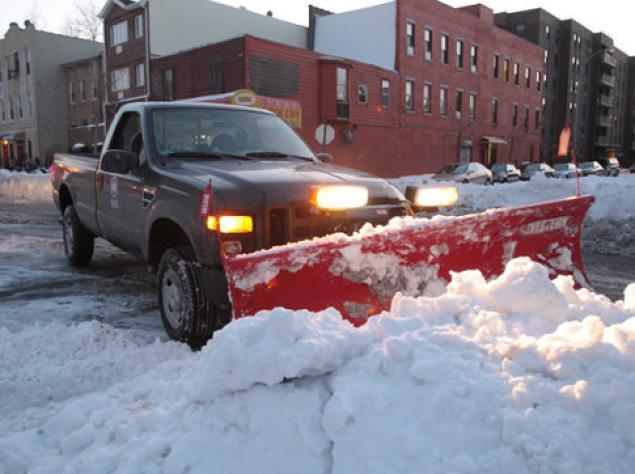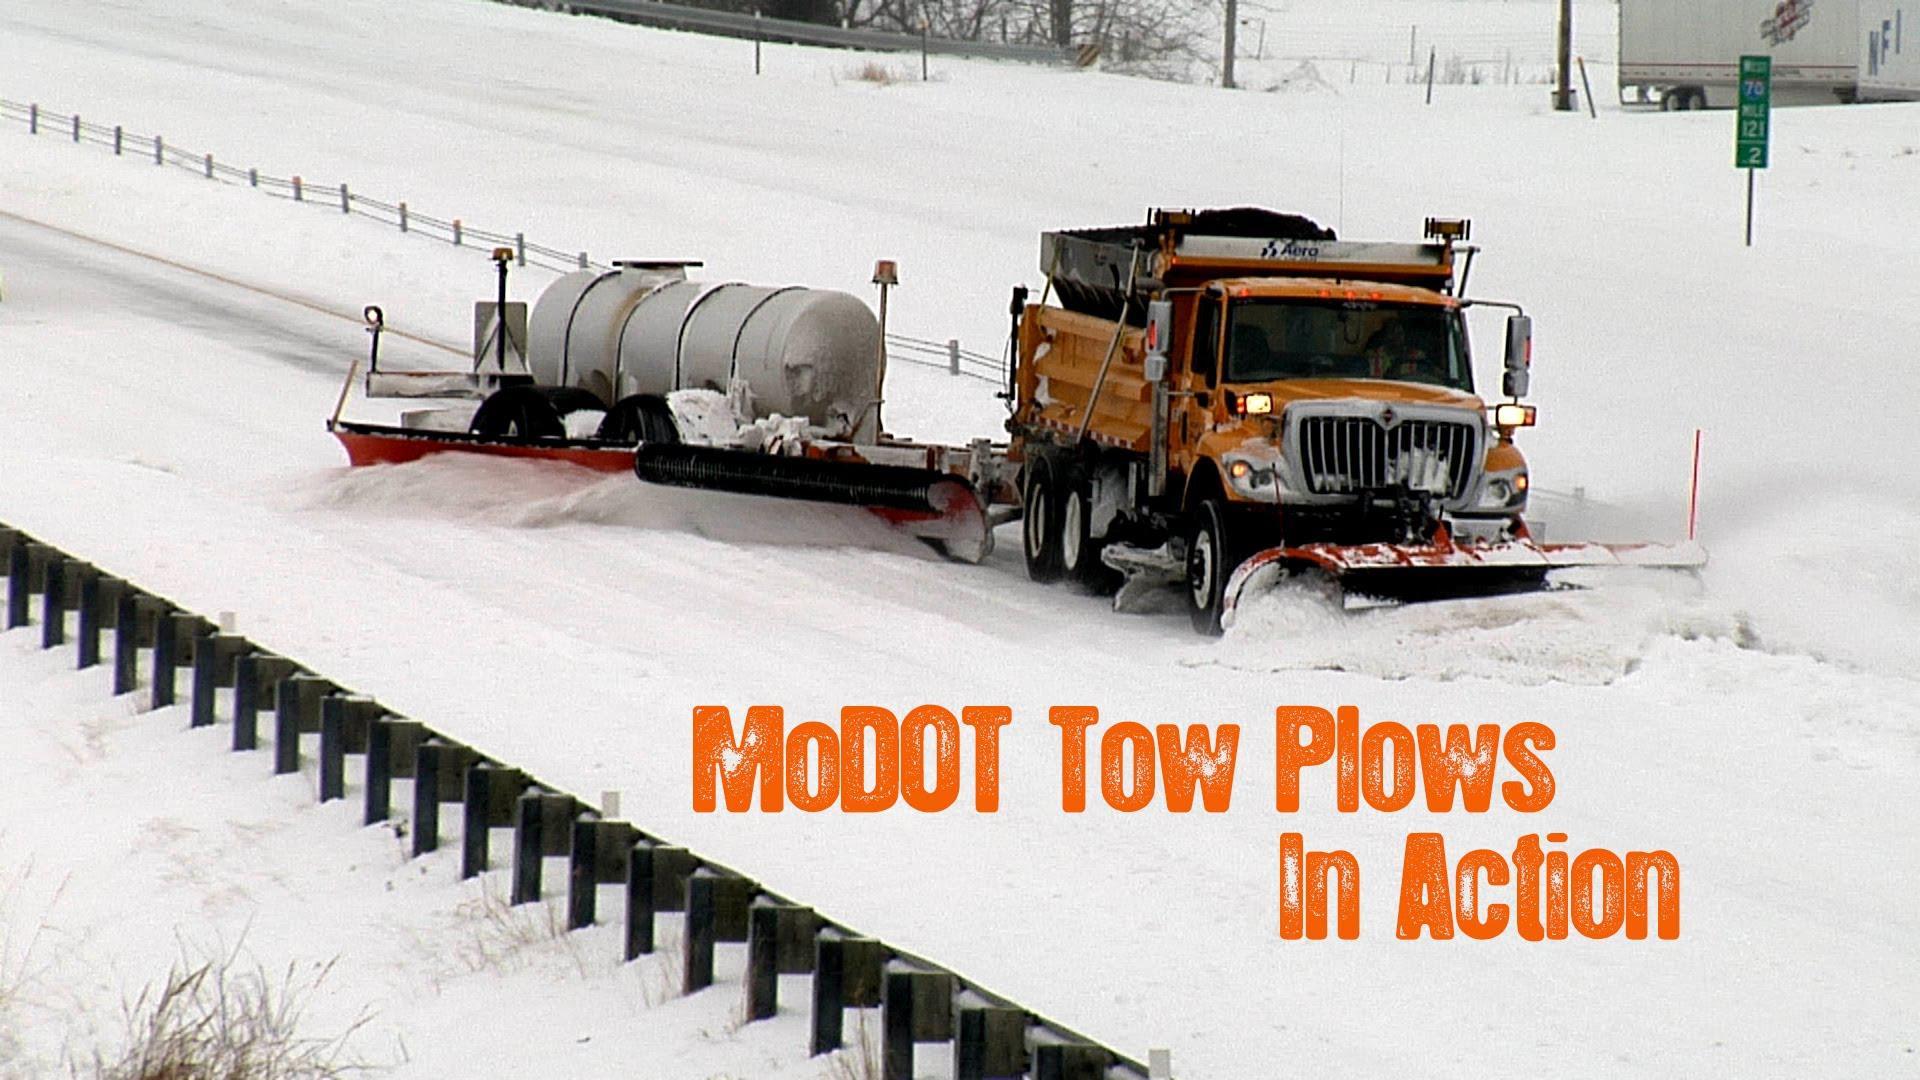The first image is the image on the left, the second image is the image on the right. For the images displayed, is the sentence "Both images feature in the foreground a tow plow pulled by a truck with a bright yellow cab." factually correct? Answer yes or no. No. 